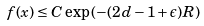Convert formula to latex. <formula><loc_0><loc_0><loc_500><loc_500>f ( x ) \leq C \exp \left ( - ( 2 d - 1 + \epsilon ) R \right )</formula> 